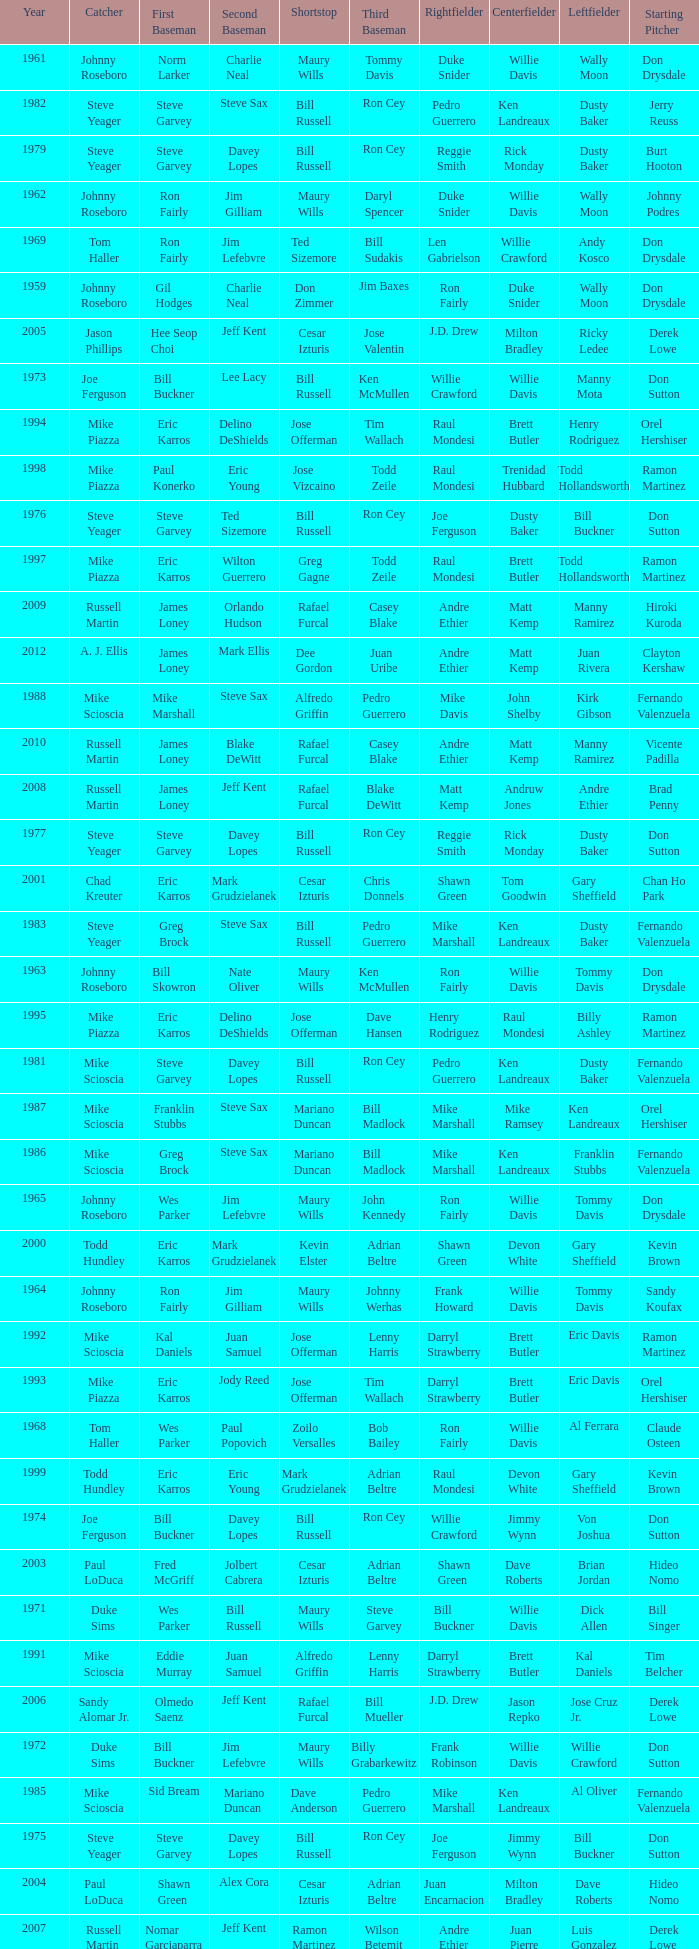Who was the RF when the SP was vicente padilla? Andre Ethier. 